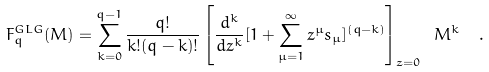<formula> <loc_0><loc_0><loc_500><loc_500>F _ { q } ^ { G L G } ( M ) = \sum _ { k = 0 } ^ { q - 1 } \frac { q ! } { k ! ( q - k ) ! } \left [ \frac { d ^ { k } } { d z ^ { k } } [ 1 + \sum _ { \mu = 1 } ^ { \infty } z ^ { \mu } s _ { \mu } ] ^ { ( q - k ) } \right ] _ { z = 0 } \ M ^ { k } \ \ .</formula> 